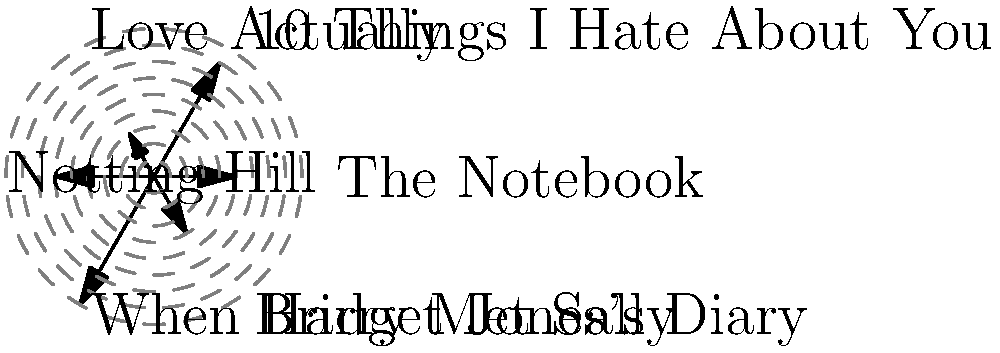In the polar histogram showing the frequency of romantic gestures in popular rom-coms, which movie exhibits the highest number of such gestures, and how does this relate to its narrative structure? To answer this question, we need to analyze the polar histogram:

1. Identify the movies represented:
   - The Notebook
   - 10 Things I Hate About You
   - Love Actually
   - Notting Hill
   - When Harry Met Sally
   - Bridget Jones's Diary

2. Compare the length of the arrows:
   - The longest arrow represents the highest frequency of romantic gestures.
   - We can see that "When Harry Met Sally" has the longest arrow.

3. Relate to narrative structure:
   - "When Harry Met Sally" spans a long period (12 years) in the characters' lives.
   - The movie is structured around multiple encounters and evolving relationships.
   - This structure allows for more opportunities to showcase romantic gestures throughout the film.

4. Consider the anthropological perspective:
   - The high frequency of romantic gestures in "When Harry Met Sally" reflects the film's focus on the development of romantic relationships over time.
   - This aligns with anthropological studies of courtship rituals and the evolution of romantic behavior in modern society.

5. Compare to other films:
   - Movies like "Love Actually" show fewer gestures, possibly due to multiple storylines dividing attention.
   - "The Notebook" has a moderate number, which might reflect its intense but more condensed timeline.
Answer: When Harry Met Sally; its extended timeline allows for more romantic gestures. 